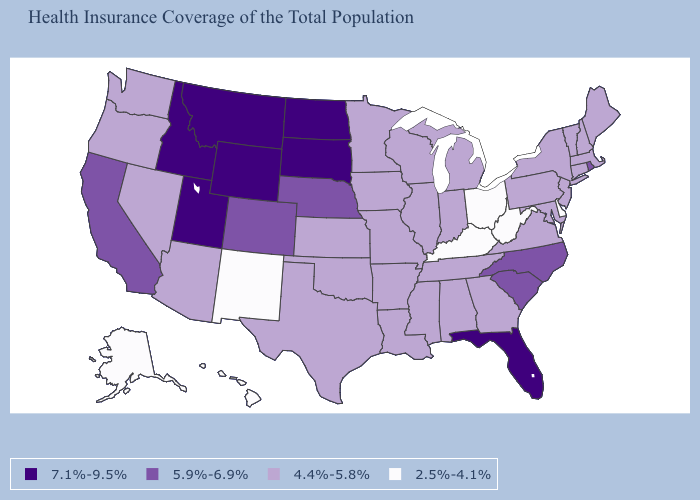Name the states that have a value in the range 5.9%-6.9%?
Concise answer only. California, Colorado, Nebraska, North Carolina, Rhode Island, South Carolina. Which states have the lowest value in the South?
Short answer required. Delaware, Kentucky, West Virginia. What is the value of New York?
Short answer required. 4.4%-5.8%. How many symbols are there in the legend?
Concise answer only. 4. What is the value of California?
Keep it brief. 5.9%-6.9%. What is the value of Maine?
Answer briefly. 4.4%-5.8%. Is the legend a continuous bar?
Keep it brief. No. Which states have the lowest value in the USA?
Write a very short answer. Alaska, Delaware, Hawaii, Kentucky, New Mexico, Ohio, West Virginia. How many symbols are there in the legend?
Concise answer only. 4. Does Nevada have a higher value than West Virginia?
Answer briefly. Yes. Does Alabama have the same value as Pennsylvania?
Quick response, please. Yes. Does Rhode Island have the lowest value in the Northeast?
Be succinct. No. Name the states that have a value in the range 2.5%-4.1%?
Give a very brief answer. Alaska, Delaware, Hawaii, Kentucky, New Mexico, Ohio, West Virginia. Among the states that border Alabama , which have the lowest value?
Give a very brief answer. Georgia, Mississippi, Tennessee. 